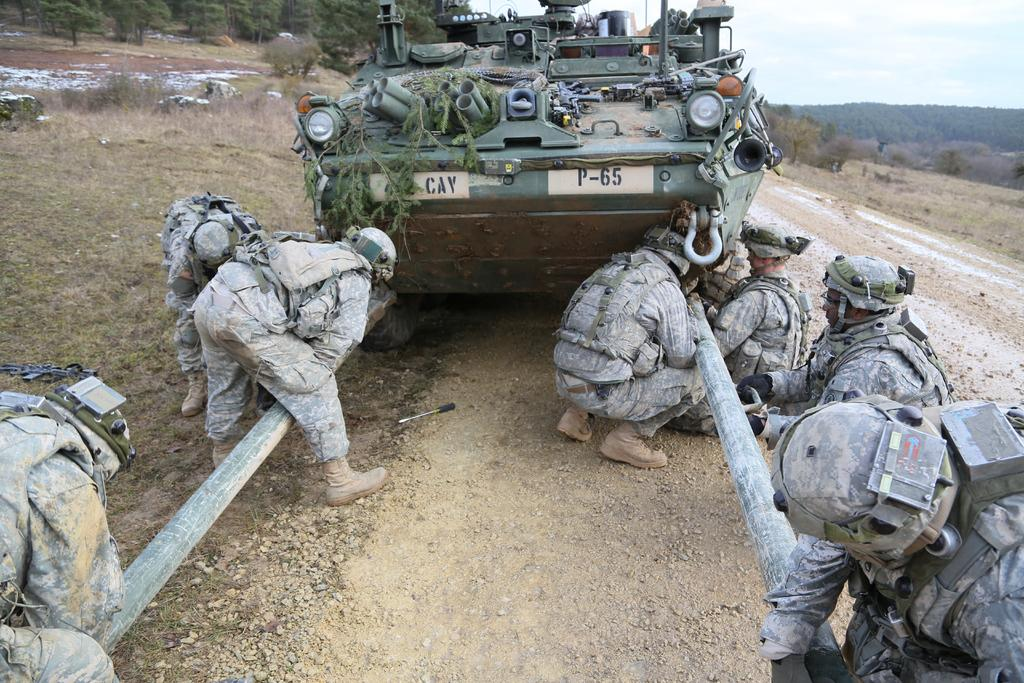What is the main subject in the center of the image? There is a military vehicle in the center of the image. Can you describe the people in the image? The people in the image are wearing uniforms. What can be seen in the background of the image? There are trees, hills, and the sky visible in the background of the image. What time of day is it in the image, based on the position of the hour? There is no hour present in the image, as it is a photograph of a military vehicle and people in uniforms. How many toes are visible on the people in the image? The image does not show the toes of the people, as they are wearing uniforms and shoes. 